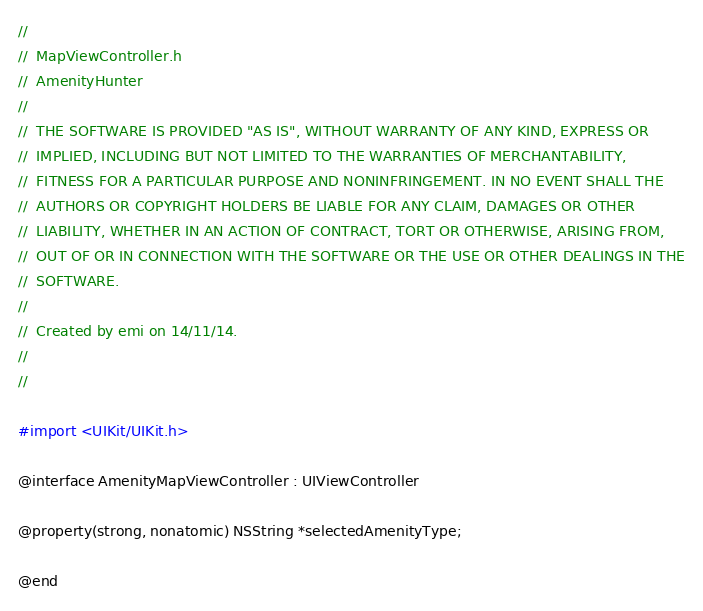<code> <loc_0><loc_0><loc_500><loc_500><_C_>//
//  MapViewController.h
//  AmenityHunter
//
//  THE SOFTWARE IS PROVIDED "AS IS", WITHOUT WARRANTY OF ANY KIND, EXPRESS OR
//  IMPLIED, INCLUDING BUT NOT LIMITED TO THE WARRANTIES OF MERCHANTABILITY,
//  FITNESS FOR A PARTICULAR PURPOSE AND NONINFRINGEMENT. IN NO EVENT SHALL THE
//  AUTHORS OR COPYRIGHT HOLDERS BE LIABLE FOR ANY CLAIM, DAMAGES OR OTHER
//  LIABILITY, WHETHER IN AN ACTION OF CONTRACT, TORT OR OTHERWISE, ARISING FROM,
//  OUT OF OR IN CONNECTION WITH THE SOFTWARE OR THE USE OR OTHER DEALINGS IN THE
//  SOFTWARE.
//
//  Created by emi on 14/11/14.
//
//

#import <UIKit/UIKit.h>

@interface AmenityMapViewController : UIViewController

@property(strong, nonatomic) NSString *selectedAmenityType;

@end
</code> 